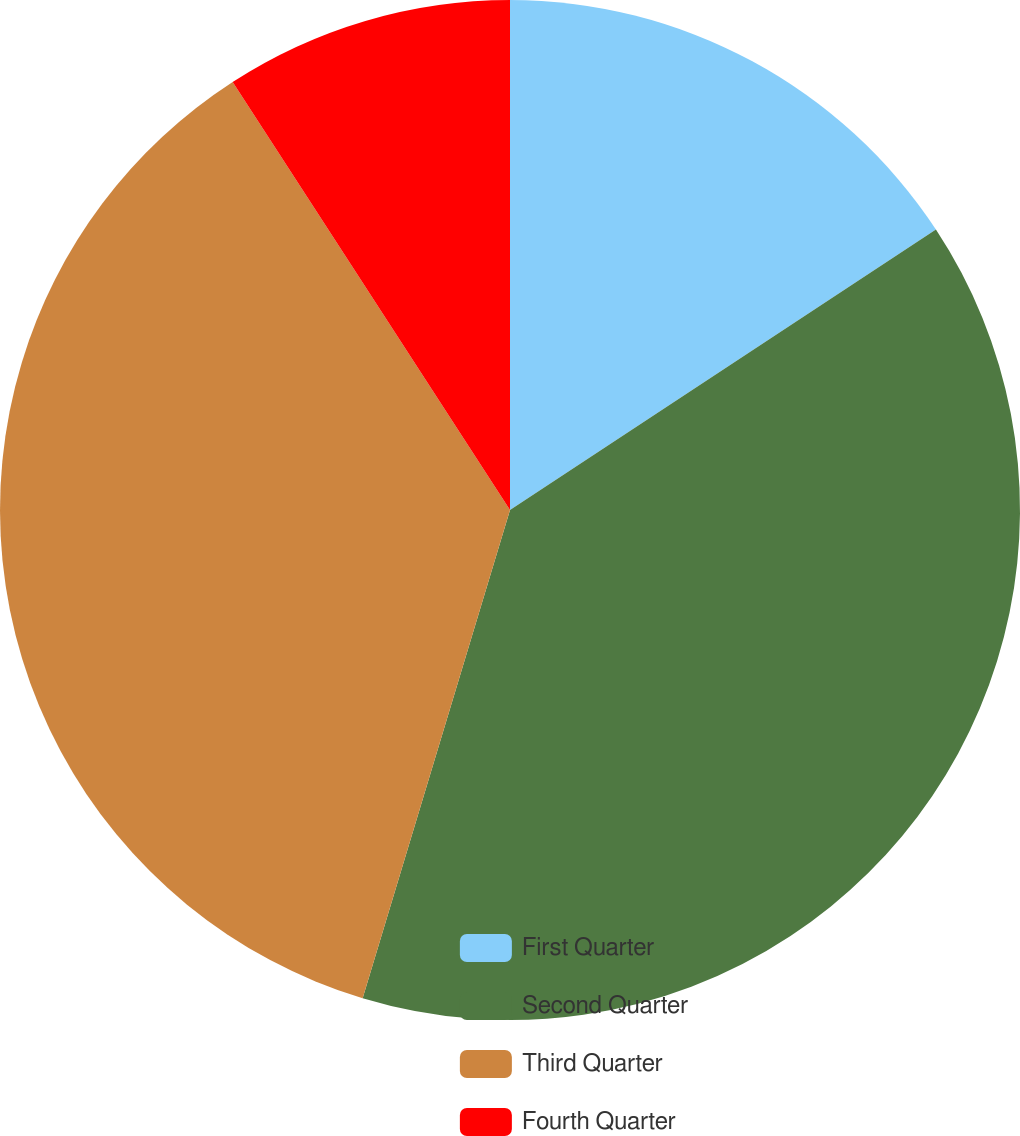Convert chart. <chart><loc_0><loc_0><loc_500><loc_500><pie_chart><fcel>First Quarter<fcel>Second Quarter<fcel>Third Quarter<fcel>Fourth Quarter<nl><fcel>15.73%<fcel>38.93%<fcel>36.18%<fcel>9.15%<nl></chart> 